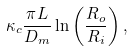<formula> <loc_0><loc_0><loc_500><loc_500>\kappa _ { c } \frac { \pi L } { D _ { m } } \ln \left ( \frac { R _ { o } } { R _ { i } } \right ) ,</formula> 